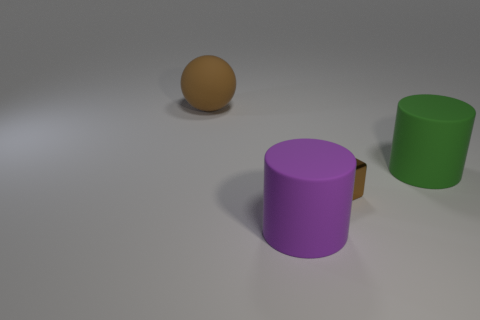Add 4 gray things. How many objects exist? 8 Subtract all cubes. How many objects are left? 3 Add 3 metal objects. How many metal objects are left? 4 Add 1 large objects. How many large objects exist? 4 Subtract 0 blue cubes. How many objects are left? 4 Subtract all tiny metal objects. Subtract all purple objects. How many objects are left? 2 